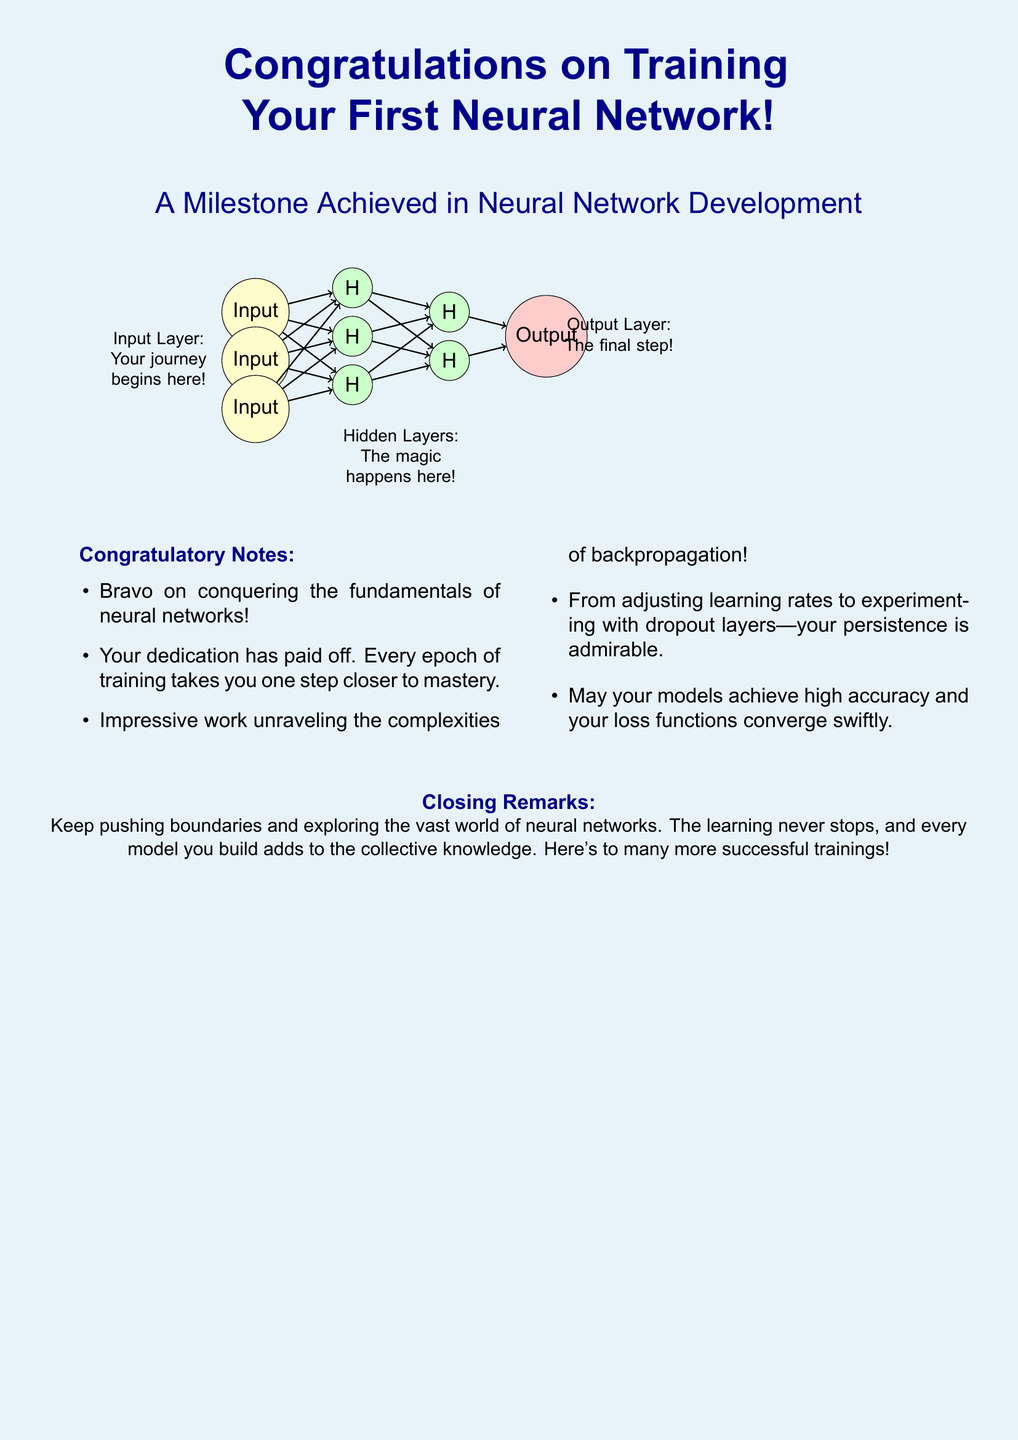What is the title of the greeting card? The title of the greeting card is presented prominently at the top of the document.
Answer: Congratulations on Training Your First Neural Network! How many input neurons are illustrated? The document visually represents three input neurons in the neural network diagram.
Answer: 3 What color are the hidden layer neurons? The color of the hidden layer neurons is specified in the document.
Answer: Green Which layer is described as 'The final step'? The output layer is directly labeled with this description in the diagram.
Answer: Output Layer What is mentioned as 'The magic happens here'? This phrase describes a specific layer in the neural network, indicating its significance.
Answer: Hidden Layers How many congratulatory notes are listed? The document contains a bulleted list of notes to celebrate the achievement.
Answer: 5 What is advised in the closing remarks? The closing remarks encourage an ongoing pursuit of knowledge in the field.
Answer: Keep pushing boundaries What is the background color of the greeting card? The background color is indicated at the start of the document's rendering and design.
Answer: Light blue 